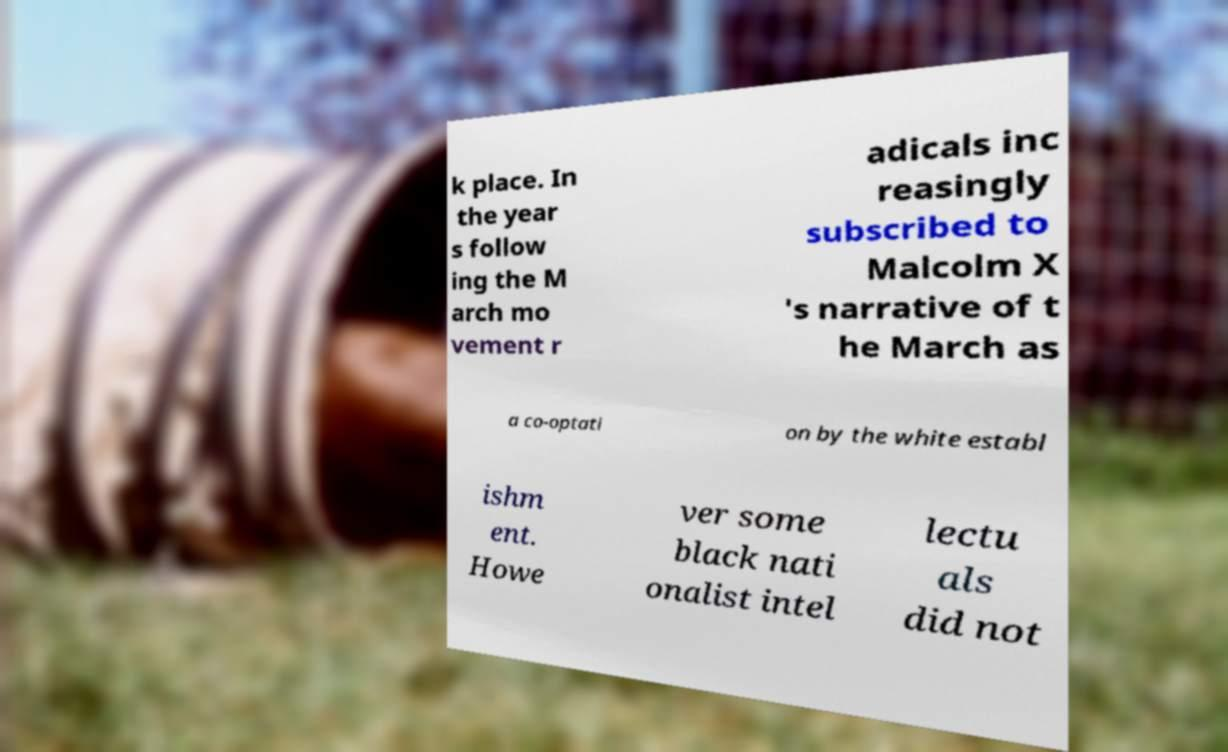Could you assist in decoding the text presented in this image and type it out clearly? k place. In the year s follow ing the M arch mo vement r adicals inc reasingly subscribed to Malcolm X 's narrative of t he March as a co-optati on by the white establ ishm ent. Howe ver some black nati onalist intel lectu als did not 